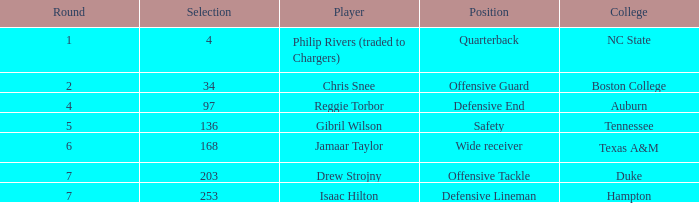Which Position has a Round larger than 5, and a Selection of 168? Wide receiver. Give me the full table as a dictionary. {'header': ['Round', 'Selection', 'Player', 'Position', 'College'], 'rows': [['1', '4', 'Philip Rivers (traded to Chargers)', 'Quarterback', 'NC State'], ['2', '34', 'Chris Snee', 'Offensive Guard', 'Boston College'], ['4', '97', 'Reggie Torbor', 'Defensive End', 'Auburn'], ['5', '136', 'Gibril Wilson', 'Safety', 'Tennessee'], ['6', '168', 'Jamaar Taylor', 'Wide receiver', 'Texas A&M'], ['7', '203', 'Drew Strojny', 'Offensive Tackle', 'Duke'], ['7', '253', 'Isaac Hilton', 'Defensive Lineman', 'Hampton']]} 